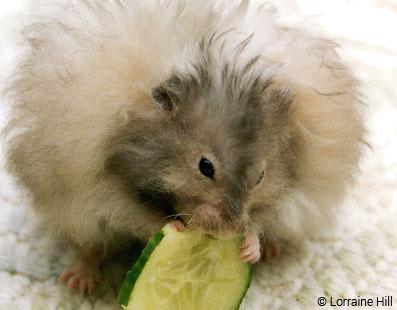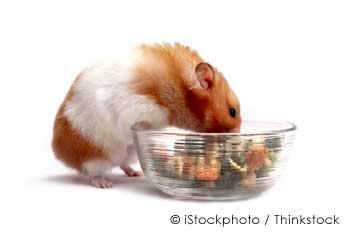The first image is the image on the left, the second image is the image on the right. Assess this claim about the two images: "An image shows an orange-and-white hamster next to a clear bowl of food.". Correct or not? Answer yes or no. Yes. The first image is the image on the left, the second image is the image on the right. For the images shown, is this caption "A hamster is eating off a clear bowl full of food." true? Answer yes or no. Yes. 